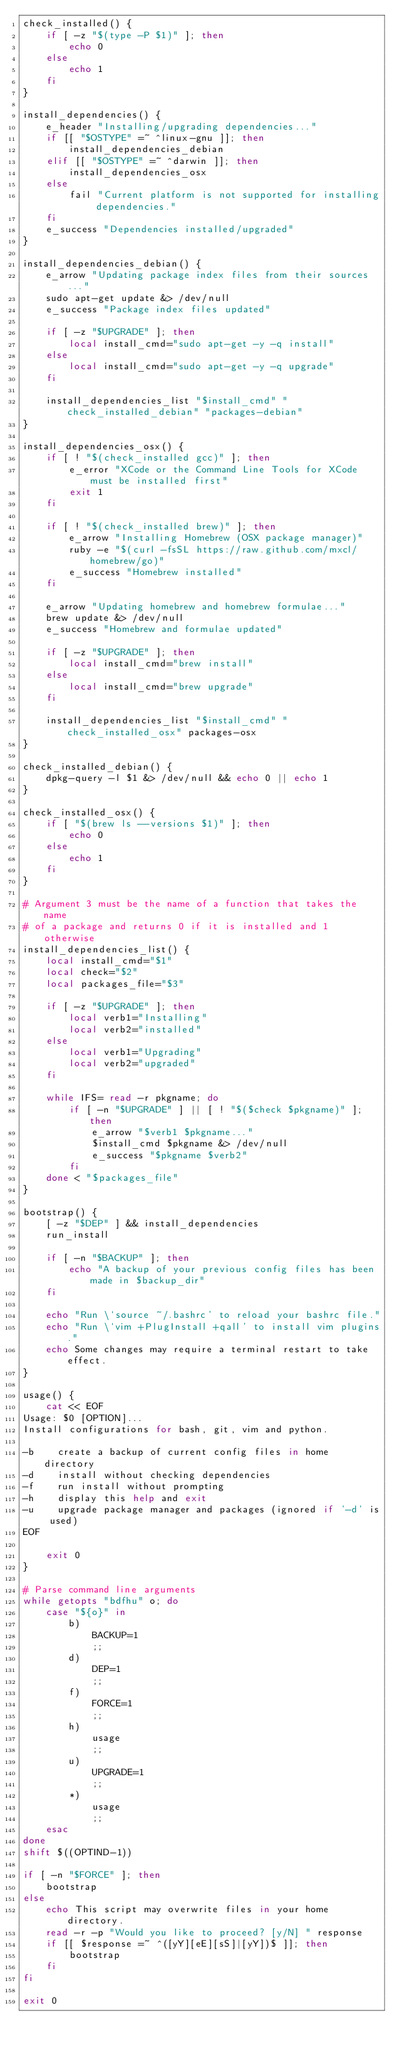<code> <loc_0><loc_0><loc_500><loc_500><_Bash_>check_installed() {
	if [ -z "$(type -P $1)" ]; then
		echo 0
	else
		echo 1
	fi
}

install_dependencies() {
	e_header "Installing/upgrading dependencies..."
	if [[ "$OSTYPE" =~ ^linux-gnu ]]; then
		install_dependencies_debian
	elif [[ "$OSTYPE" =~ ^darwin ]]; then
		install_dependencies_osx
	else
		fail "Current platform is not supported for installing dependencies."
	fi
	e_success "Dependencies installed/upgraded"
}

install_dependencies_debian() {
	e_arrow "Updating package index files from their sources..."
	sudo apt-get update &> /dev/null
	e_success "Package index files updated"

	if [ -z "$UPGRADE" ]; then
		local install_cmd="sudo apt-get -y -q install"
	else
		local install_cmd="sudo apt-get -y -q upgrade"
	fi

	install_dependencies_list "$install_cmd" "check_installed_debian" "packages-debian"
}

install_dependencies_osx() {
	if [ ! "$(check_installed gcc)" ]; then
		e_error "XCode or the Command Line Tools for XCode must be installed first"
		exit 1
	fi
	
	if [ ! "$(check_installed brew)" ]; then
		e_arrow "Installing Homebrew (OSX package manager)"
		ruby -e "$(curl -fsSL https://raw.github.com/mxcl/homebrew/go)"
		e_success "Homebrew installed"
	fi

	e_arrow "Updating homebrew and homebrew formulae..."
	brew update &> /dev/null
	e_success "Homebrew and formulae updated"

	if [ -z "$UPGRADE" ]; then
		local install_cmd="brew install"
	else
		local install_cmd="brew upgrade"
	fi

	install_dependencies_list "$install_cmd" "check_installed_osx" packages-osx
}

check_installed_debian() {
	dpkg-query -l $1 &> /dev/null && echo 0 || echo 1
}

check_installed_osx() {
	if [ "$(brew ls --versions $1)" ]; then
		echo 0
	else
		echo 1
	fi
}

# Argument 3 must be the name of a function that takes the name 
# of a package and returns 0 if it is installed and 1 otherwise
install_dependencies_list() {
	local install_cmd="$1"
	local check="$2"
	local packages_file="$3"

	if [ -z "$UPGRADE" ]; then
		local verb1="Installing"
		local verb2="installed"
	else
		local verb1="Upgrading"
		local verb2="upgraded"
	fi

	while IFS= read -r pkgname; do
		if [ -n "$UPGRADE" ] || [ ! "$($check $pkgname)" ]; then
			e_arrow "$verb1 $pkgname..."
			$install_cmd $pkgname &> /dev/null
			e_success "$pkgname $verb2"
		fi
	done < "$packages_file"
}

bootstrap() {
	[ -z "$DEP" ] && install_dependencies
	run_install

	if [ -n "$BACKUP" ]; then
		echo "A backup of your previous config files has been made in $backup_dir"
	fi

	echo "Run \`source ~/.bashrc' to reload your bashrc file."
	echo "Run \`vim +PlugInstall +qall' to install vim plugins."
	echo Some changes may require a terminal restart to take effect.
}

usage() {
	cat << EOF
Usage: $0 [OPTION]...
Install configurations for bash, git, vim and python.

-b    create a backup of current config files in home directory
-d    install without checking dependencies
-f    run install without prompting
-h    display this help and exit
-u    upgrade package manager and packages (ignored if '-d' is used)
EOF

	exit 0
}

# Parse command line arguments
while getopts "bdfhu" o; do
	case "${o}" in 
		b)
			BACKUP=1
			;;
		d)
			DEP=1
			;;
		f)
			FORCE=1
			;;
		h)
			usage
			;;
		u)
			UPGRADE=1
			;;
		*)
			usage
			;;
	esac
done
shift $((OPTIND-1))

if [ -n "$FORCE" ]; then
	bootstrap
else 
	echo This script may overwrite files in your home directory.
	read -r -p "Would you like to proceed? [y/N] " response
	if [[ $response =~ ^([yY][eE][sS]|[yY])$ ]]; then
		bootstrap
	fi
fi

exit 0
</code> 